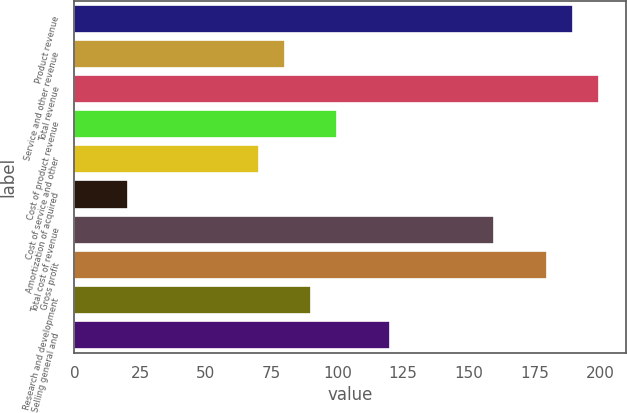Convert chart. <chart><loc_0><loc_0><loc_500><loc_500><bar_chart><fcel>Product revenue<fcel>Service and other revenue<fcel>Total revenue<fcel>Cost of product revenue<fcel>Cost of service and other<fcel>Amortization of acquired<fcel>Total cost of revenue<fcel>Gross profit<fcel>Research and development<fcel>Selling general and<nl><fcel>189.73<fcel>80.06<fcel>199.7<fcel>100<fcel>70.09<fcel>20.24<fcel>159.82<fcel>179.76<fcel>90.03<fcel>119.94<nl></chart> 